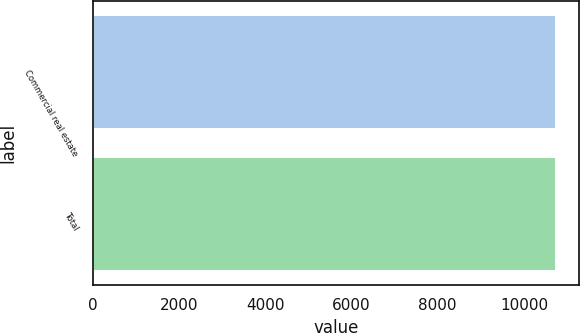Convert chart. <chart><loc_0><loc_0><loc_500><loc_500><bar_chart><fcel>Commercial real estate<fcel>Total<nl><fcel>10750<fcel>10750.1<nl></chart> 